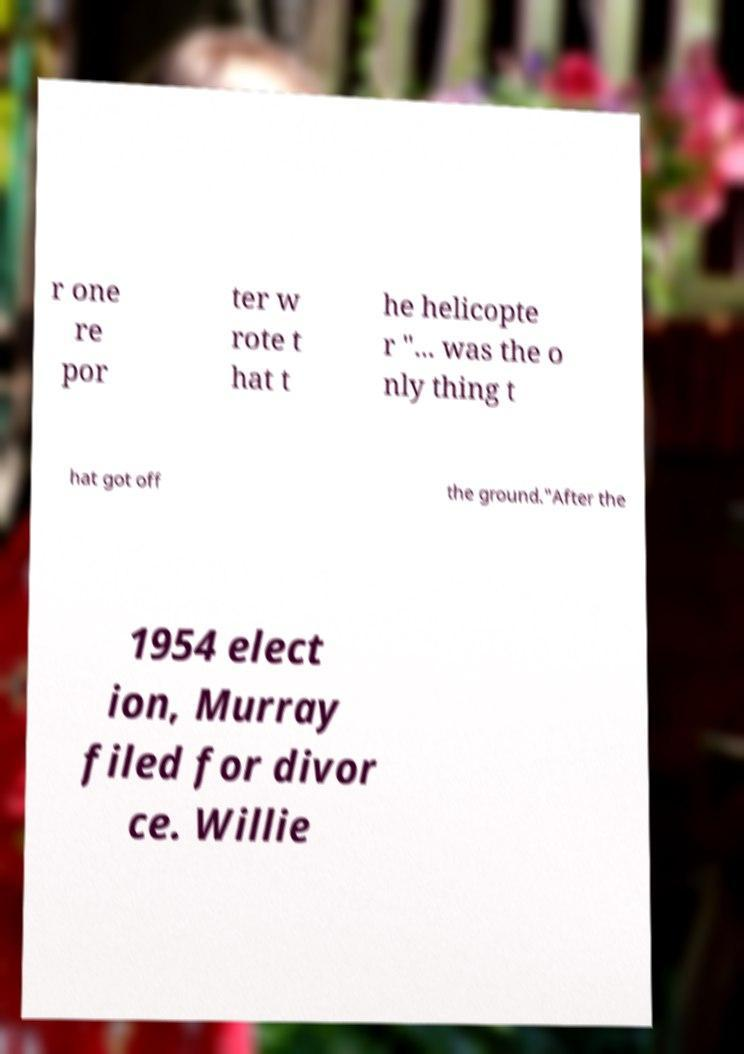For documentation purposes, I need the text within this image transcribed. Could you provide that? r one re por ter w rote t hat t he helicopte r "... was the o nly thing t hat got off the ground."After the 1954 elect ion, Murray filed for divor ce. Willie 